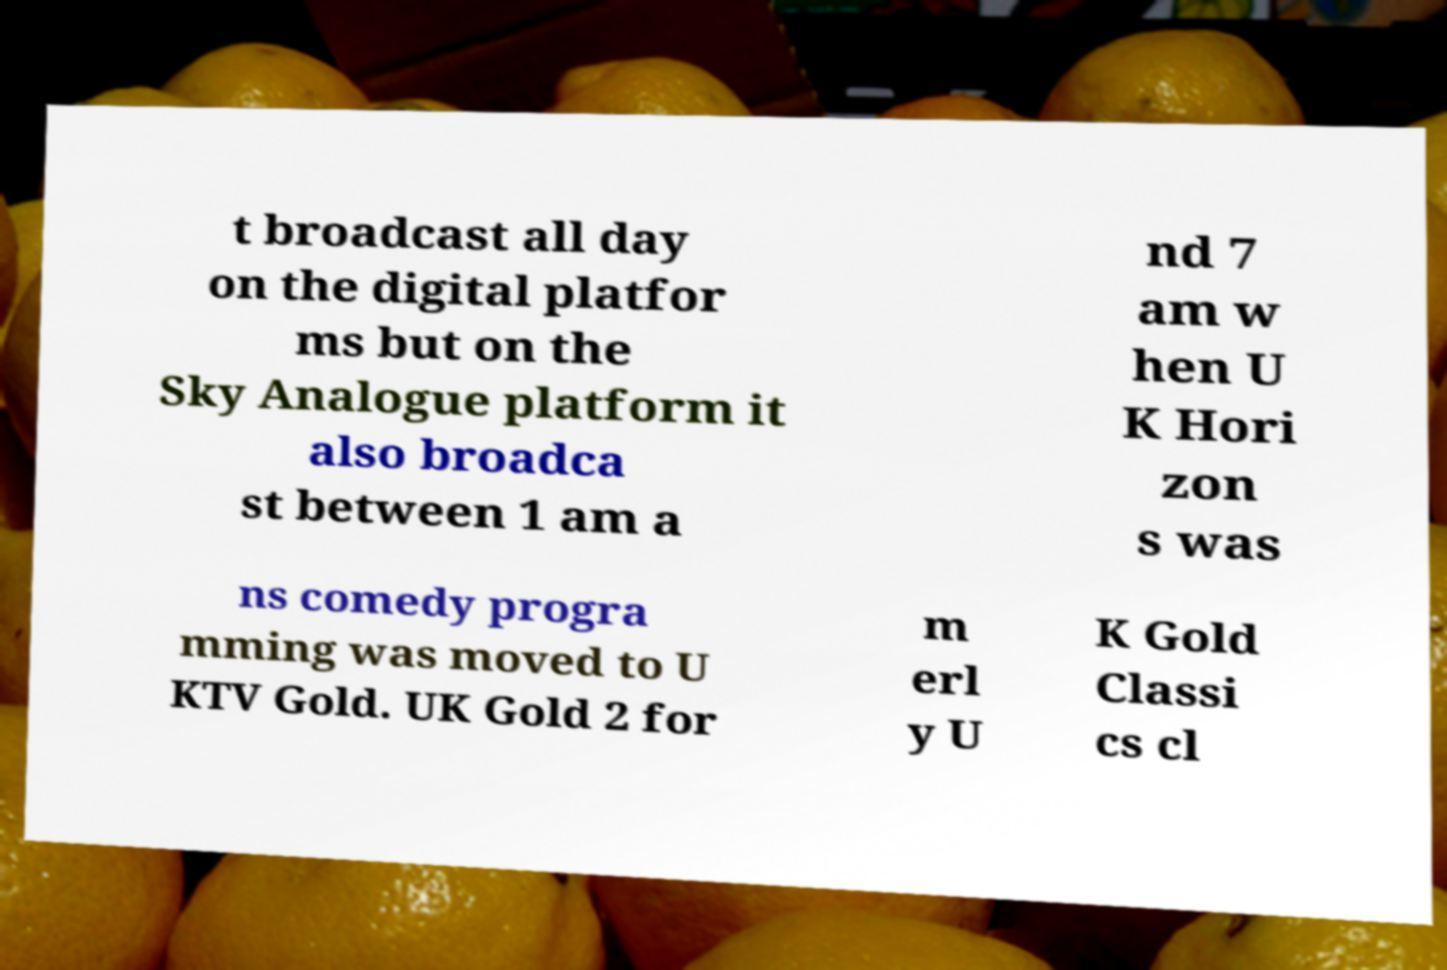I need the written content from this picture converted into text. Can you do that? t broadcast all day on the digital platfor ms but on the Sky Analogue platform it also broadca st between 1 am a nd 7 am w hen U K Hori zon s was ns comedy progra mming was moved to U KTV Gold. UK Gold 2 for m erl y U K Gold Classi cs cl 